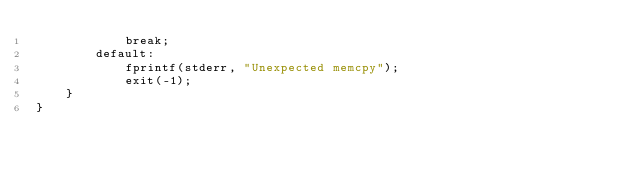<code> <loc_0><loc_0><loc_500><loc_500><_Cuda_>            break;
        default:
            fprintf(stderr, "Unexpected memcpy");
            exit(-1);
    }
}
</code> 